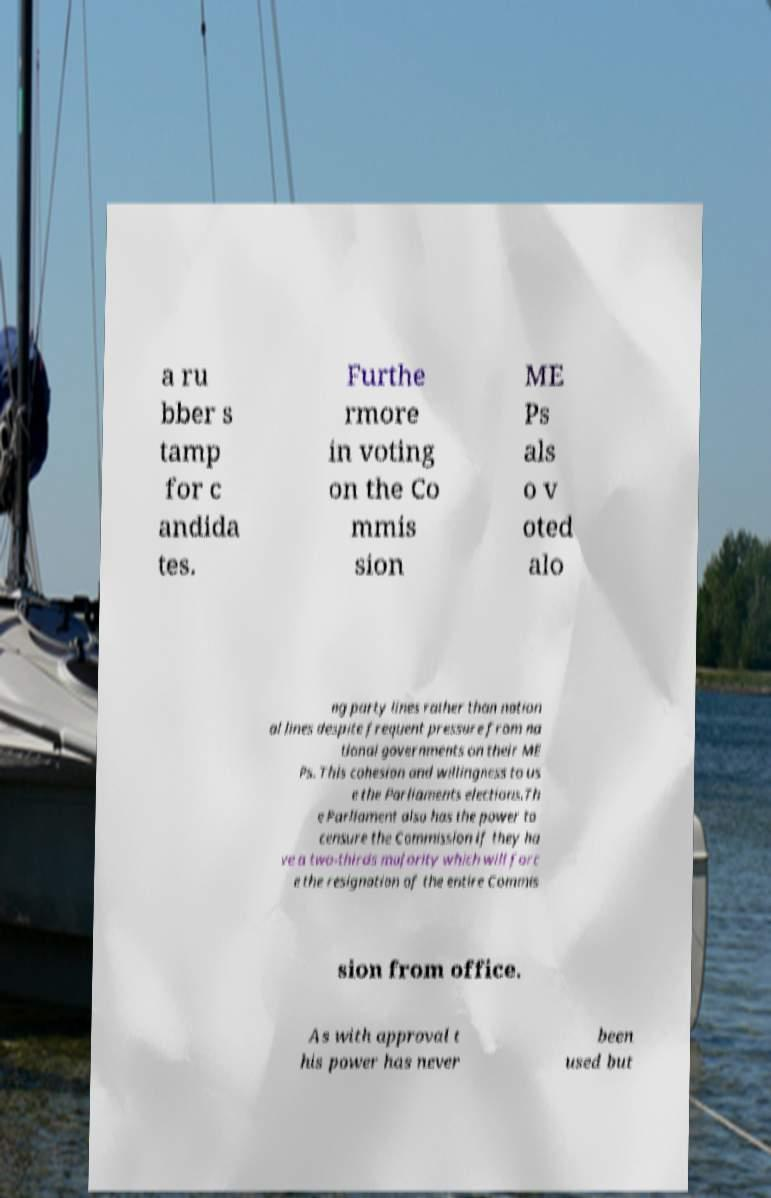What messages or text are displayed in this image? I need them in a readable, typed format. a ru bber s tamp for c andida tes. Furthe rmore in voting on the Co mmis sion ME Ps als o v oted alo ng party lines rather than nation al lines despite frequent pressure from na tional governments on their ME Ps. This cohesion and willingness to us e the Parliaments elections.Th e Parliament also has the power to censure the Commission if they ha ve a two-thirds majority which will forc e the resignation of the entire Commis sion from office. As with approval t his power has never been used but 